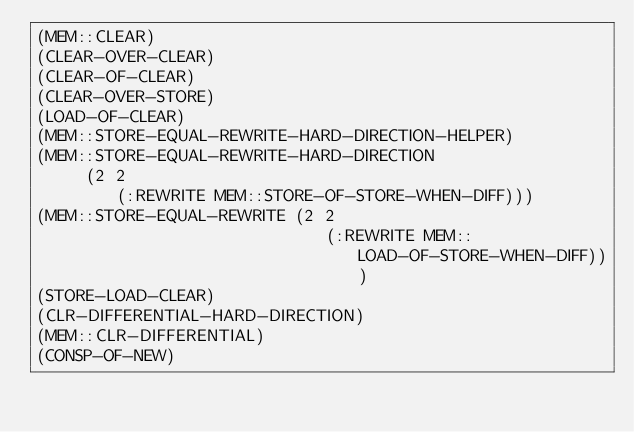<code> <loc_0><loc_0><loc_500><loc_500><_Lisp_>(MEM::CLEAR)
(CLEAR-OVER-CLEAR)
(CLEAR-OF-CLEAR)
(CLEAR-OVER-STORE)
(LOAD-OF-CLEAR)
(MEM::STORE-EQUAL-REWRITE-HARD-DIRECTION-HELPER)
(MEM::STORE-EQUAL-REWRITE-HARD-DIRECTION
     (2 2
        (:REWRITE MEM::STORE-OF-STORE-WHEN-DIFF)))
(MEM::STORE-EQUAL-REWRITE (2 2
                             (:REWRITE MEM::LOAD-OF-STORE-WHEN-DIFF)))
(STORE-LOAD-CLEAR)
(CLR-DIFFERENTIAL-HARD-DIRECTION)
(MEM::CLR-DIFFERENTIAL)
(CONSP-OF-NEW)
</code> 